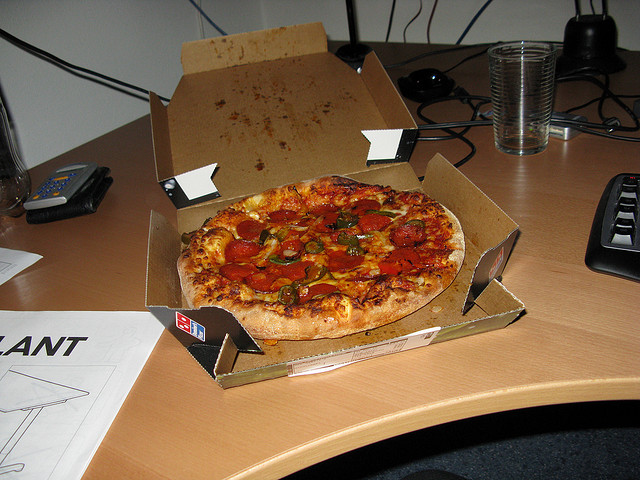Explain the visual content of the image in great detail. The scene captures an office desk setting with an appetizing pizza positioned prominently in its center, adorned with numerous pepper toppings. Scattered around the desk are various objects: a calculator and a wallet are to the left, while a computer keyboard is found on the rightmost side. Additionally, a transparent drink container, possibly a glass filled with a liquid, stands towards the upper right corner of the desk. Surrounding the pizza is its cardboard box. The desk spans the entire width of the image, forming the base for all the aforementioned items. 